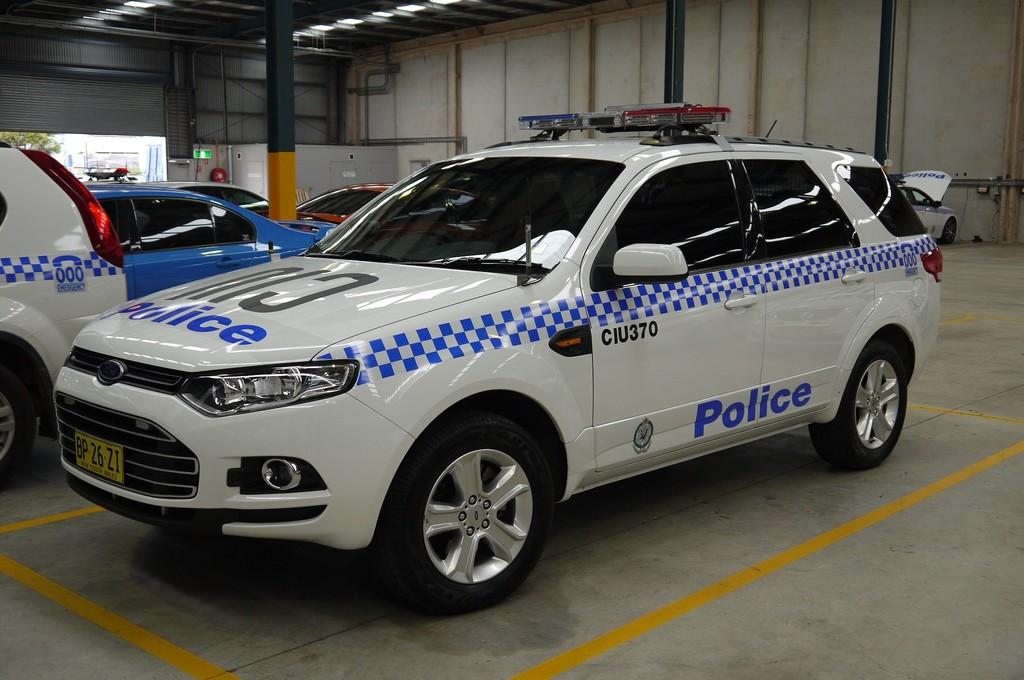What type of objects are present in the image? There are vehicles in the image. What specific features do the vehicles have? The vehicles have glass windows and wheels. What else can be seen in the image besides the vehicles? Lights are attached to a shed, there is a tree, pillars, a board, and a wall visible in the image. What type of bed can be seen in the image? There is no bed present in the image. What color is the thread used to sew the sky in the image? There is no thread or sky present in the image; it features vehicles, a shed, a tree, pillars, a board, and a wall. 